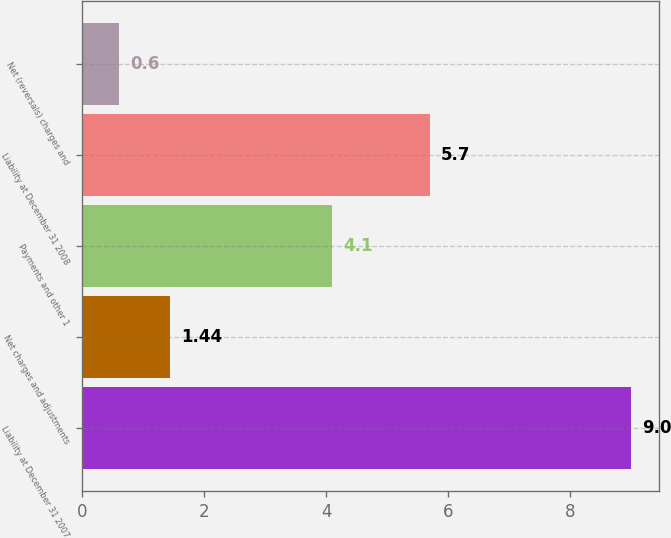<chart> <loc_0><loc_0><loc_500><loc_500><bar_chart><fcel>Liability at December 31 2007<fcel>Net charges and adjustments<fcel>Payments and other 1<fcel>Liability at December 31 2008<fcel>Net (reversals) charges and<nl><fcel>9<fcel>1.44<fcel>4.1<fcel>5.7<fcel>0.6<nl></chart> 